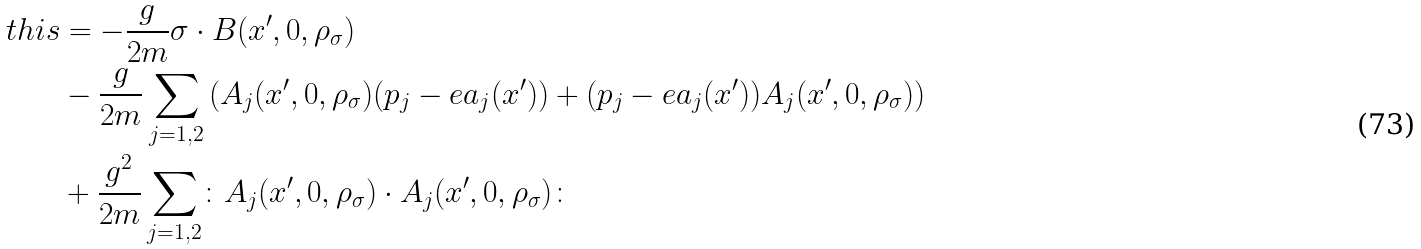Convert formula to latex. <formula><loc_0><loc_0><loc_500><loc_500>\ t h i s & = - \frac { g } { 2 m } \sigma \cdot B ( x ^ { \prime } , 0 , \rho _ { \sigma } ) \\ & - \frac { g } { 2 m } \sum _ { j = 1 , 2 } \left ( A _ { j } ( x ^ { \prime } , 0 , \rho _ { \sigma } ) ( p _ { j } - e a _ { j } ( x ^ { \prime } ) ) + ( p _ { j } - e a _ { j } ( x ^ { \prime } ) ) A _ { j } ( x ^ { \prime } , 0 , \rho _ { \sigma } ) \right ) \\ & + \frac { g ^ { 2 } } { 2 m } \sum _ { j = 1 , 2 } \colon A _ { j } ( x ^ { \prime } , 0 , \rho _ { \sigma } ) \cdot A _ { j } ( x ^ { \prime } , 0 , \rho _ { \sigma } ) \colon</formula> 